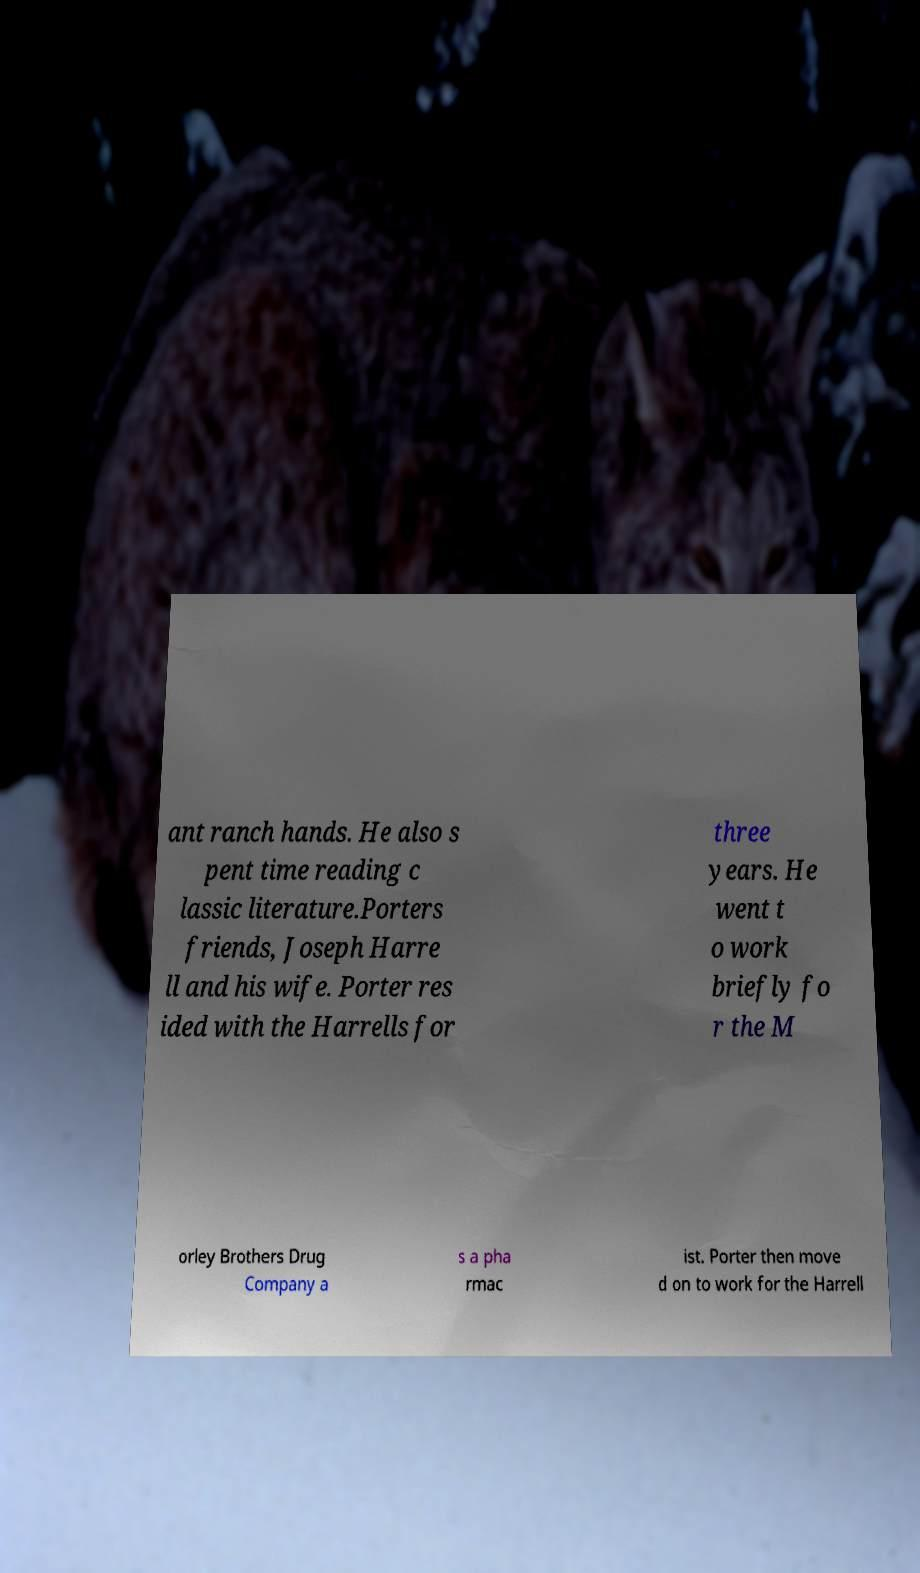What messages or text are displayed in this image? I need them in a readable, typed format. ant ranch hands. He also s pent time reading c lassic literature.Porters friends, Joseph Harre ll and his wife. Porter res ided with the Harrells for three years. He went t o work briefly fo r the M orley Brothers Drug Company a s a pha rmac ist. Porter then move d on to work for the Harrell 